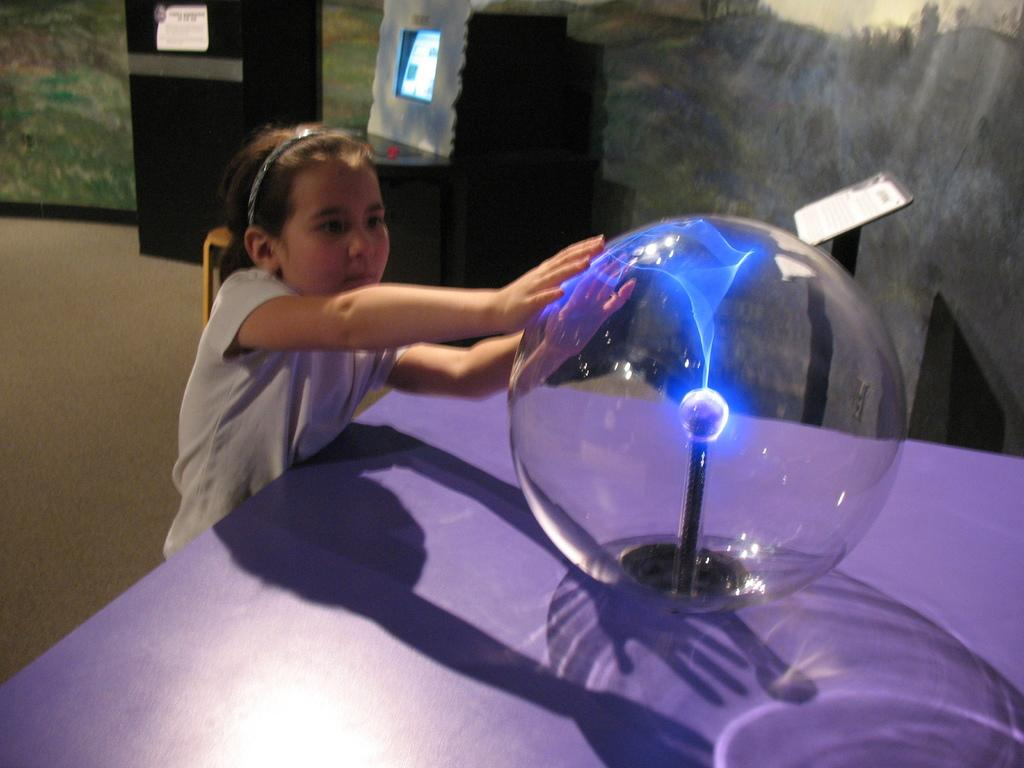Who is the main subject in the image? There is a girl standing in the image. What is the girl holding in the image? The girl is holding a plasma ball. Where is the plasma ball located in the image? The plasma ball is on a table. What can be seen in the background of the image? There are boards visible in the background of the image. What type of root can be seen growing from the plasma ball in the image? There is no root growing from the plasma ball in the image; it is an electrical device that emits light. 